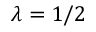<formula> <loc_0><loc_0><loc_500><loc_500>\lambda = 1 / 2</formula> 